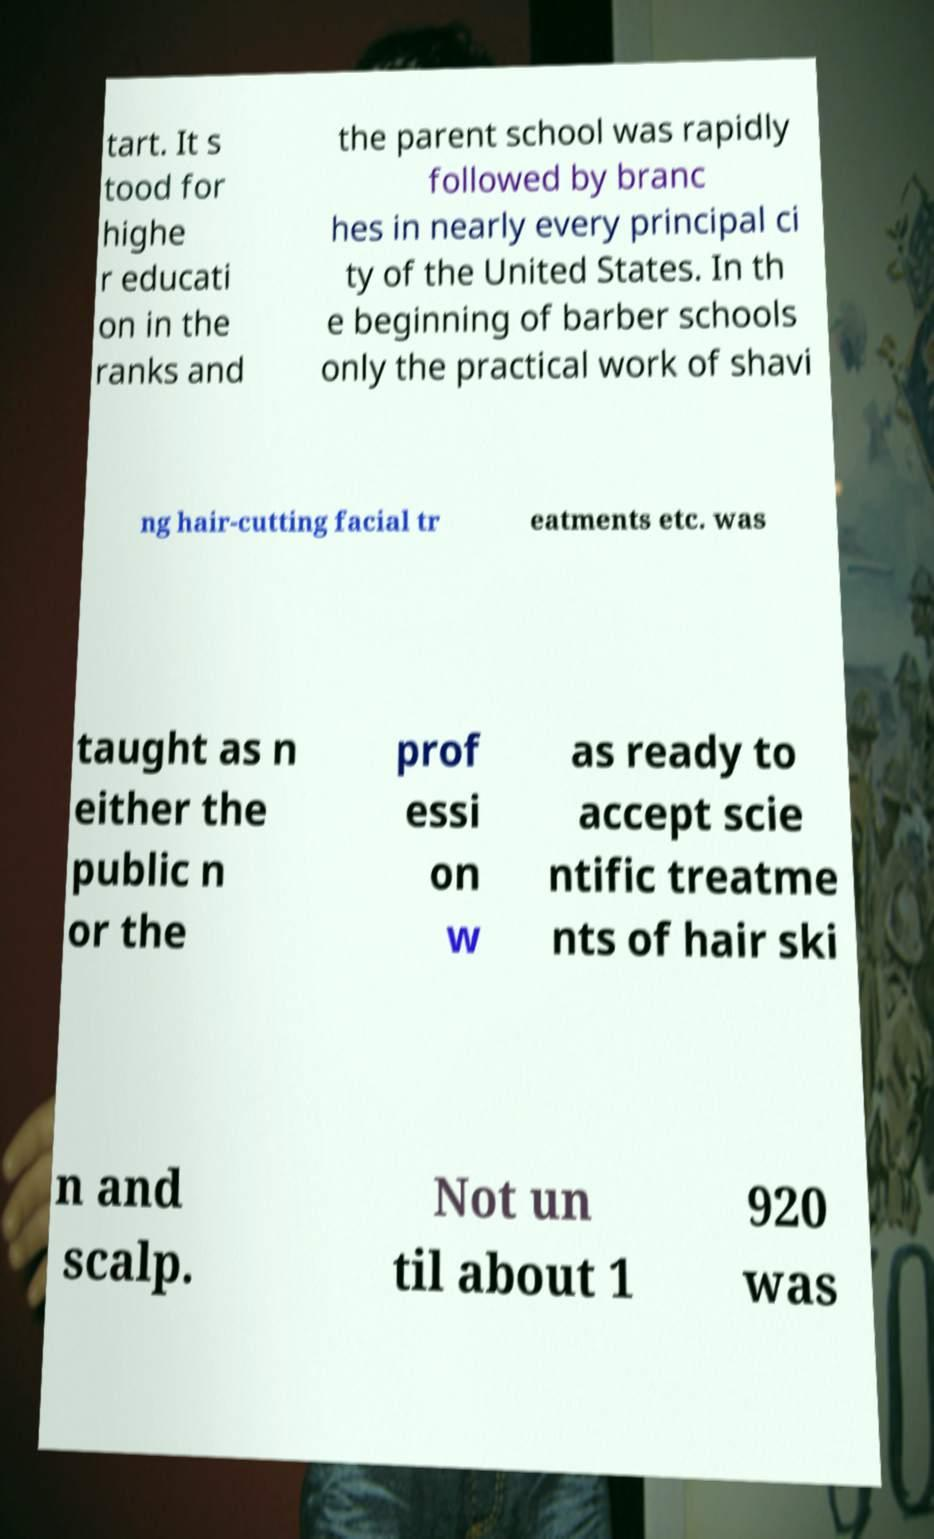Can you accurately transcribe the text from the provided image for me? tart. It s tood for highe r educati on in the ranks and the parent school was rapidly followed by branc hes in nearly every principal ci ty of the United States. In th e beginning of barber schools only the practical work of shavi ng hair-cutting facial tr eatments etc. was taught as n either the public n or the prof essi on w as ready to accept scie ntific treatme nts of hair ski n and scalp. Not un til about 1 920 was 